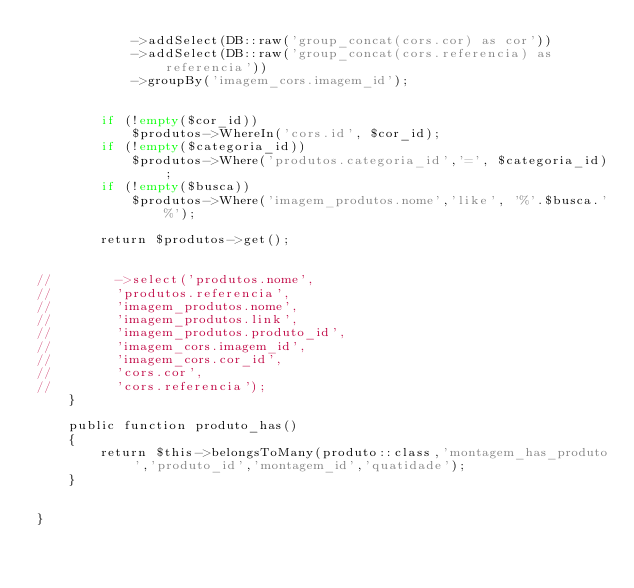<code> <loc_0><loc_0><loc_500><loc_500><_PHP_>            ->addSelect(DB::raw('group_concat(cors.cor) as cor'))
            ->addSelect(DB::raw('group_concat(cors.referencia) as referencia'))
            ->groupBy('imagem_cors.imagem_id');


        if (!empty($cor_id))
            $produtos->WhereIn('cors.id', $cor_id);
        if (!empty($categoria_id))
            $produtos->Where('produtos.categoria_id','=', $categoria_id);
        if (!empty($busca))
            $produtos->Where('imagem_produtos.nome','like', '%'.$busca.'%');

        return $produtos->get();


//        ->select('produtos.nome',
//        'produtos.referencia',
//        'imagem_produtos.nome',
//        'imagem_produtos.link',
//        'imagem_produtos.produto_id',
//        'imagem_cors.imagem_id',
//        'imagem_cors.cor_id',
//        'cors.cor',
//        'cors.referencia');
    }

    public function produto_has()
    {
        return $this->belongsToMany(produto::class,'montagem_has_produto','produto_id','montagem_id','quatidade');
    }


}
</code> 